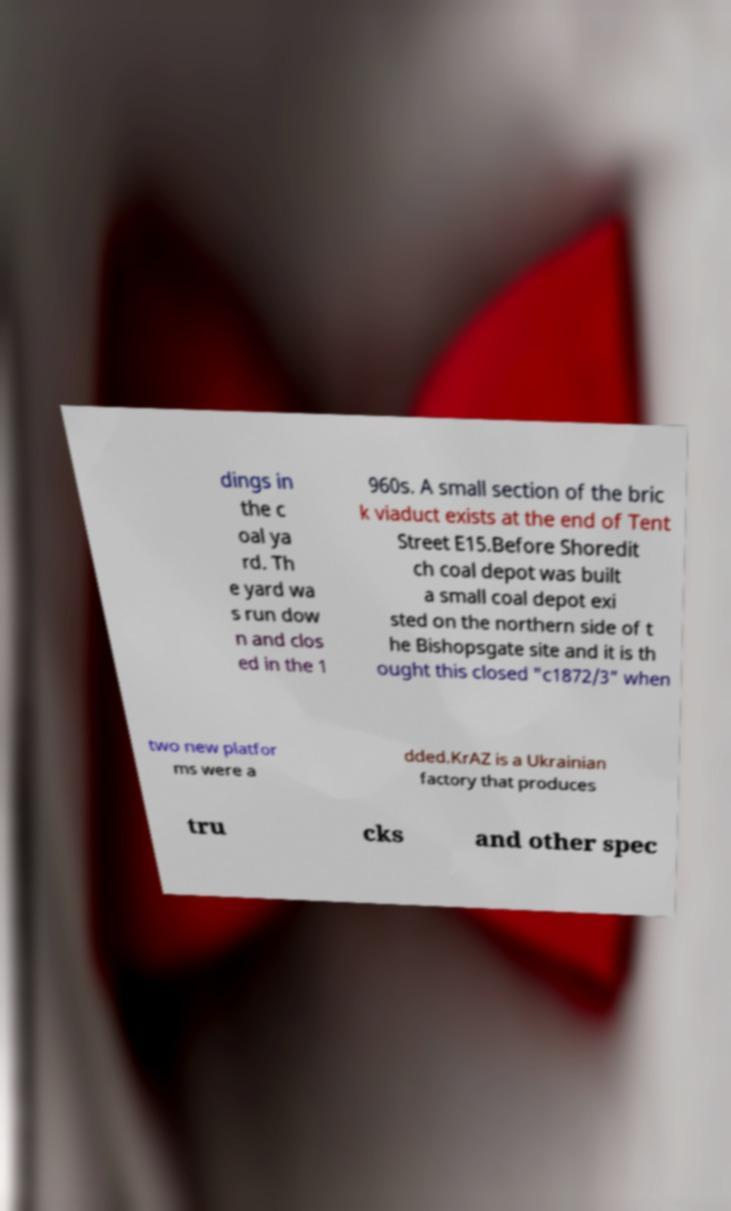Could you assist in decoding the text presented in this image and type it out clearly? dings in the c oal ya rd. Th e yard wa s run dow n and clos ed in the 1 960s. A small section of the bric k viaduct exists at the end of Tent Street E15.Before Shoredit ch coal depot was built a small coal depot exi sted on the northern side of t he Bishopsgate site and it is th ought this closed "c1872/3" when two new platfor ms were a dded.KrAZ is a Ukrainian factory that produces tru cks and other spec 